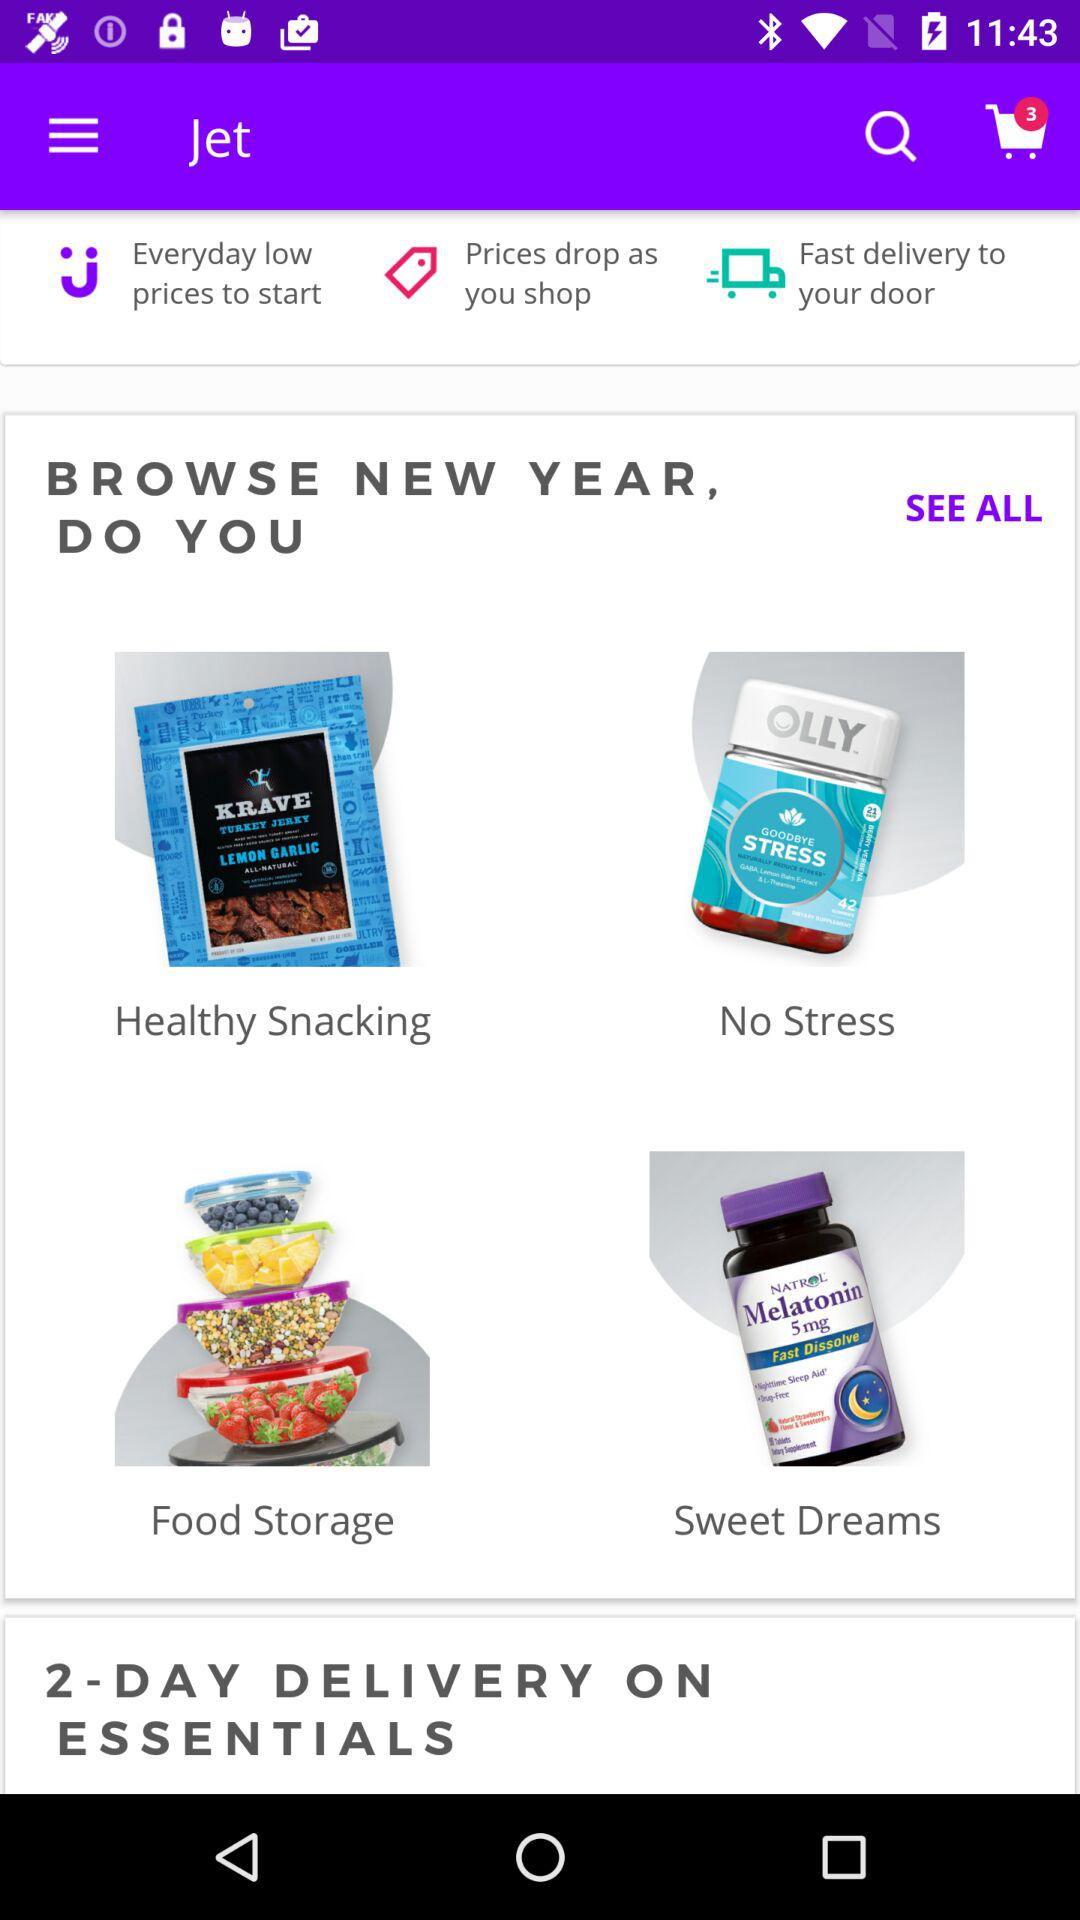What is the application name? The application name is "Jet". 